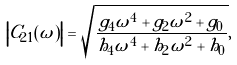<formula> <loc_0><loc_0><loc_500><loc_500>\left | C _ { 2 1 } ( \omega ) \right | = \sqrt { \frac { g _ { 4 } \omega ^ { 4 } + g _ { 2 } \omega ^ { 2 } + g _ { 0 } } { h _ { 4 } \omega ^ { 4 } + h _ { 2 } \omega ^ { 2 } + h _ { 0 } } } ,</formula> 